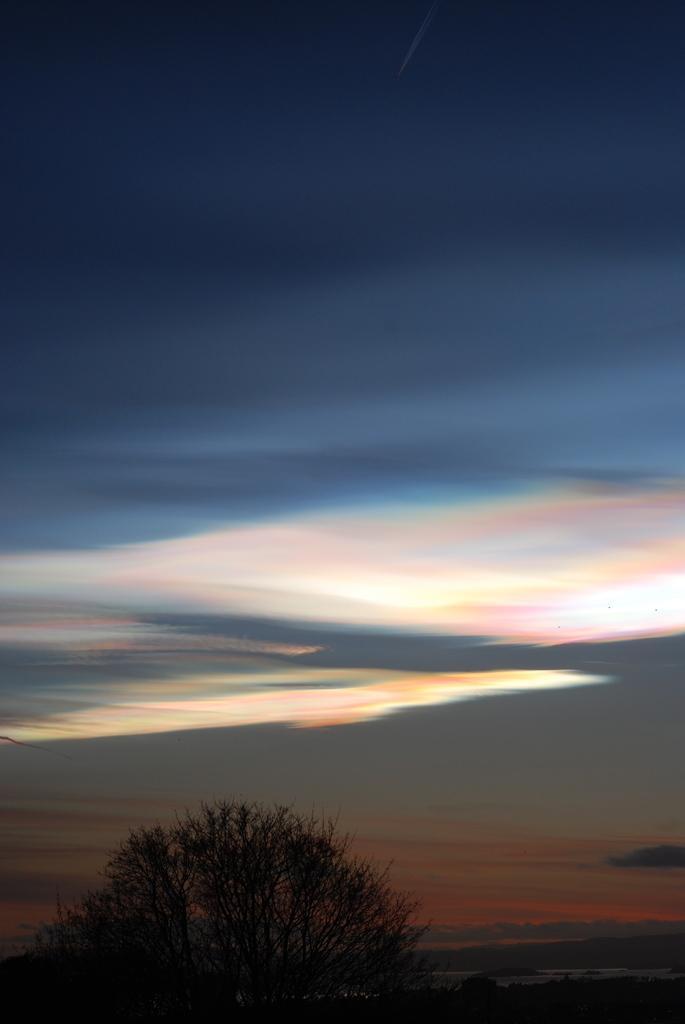Please provide a concise description of this image. In this image there are some trees at bottom of this image and there is a sky at top of this image. 